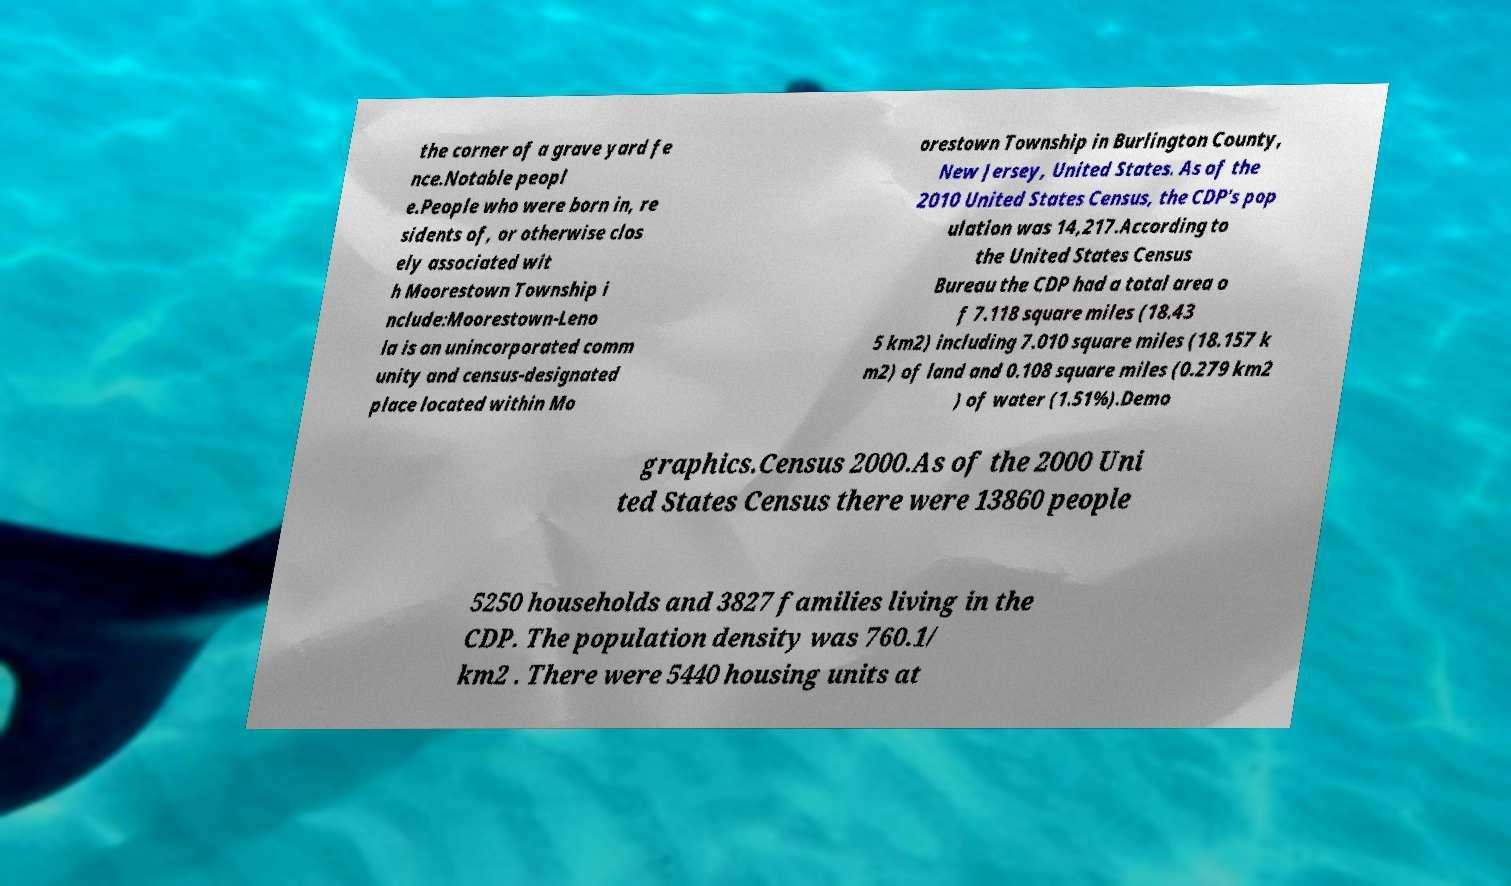Could you assist in decoding the text presented in this image and type it out clearly? the corner of a grave yard fe nce.Notable peopl e.People who were born in, re sidents of, or otherwise clos ely associated wit h Moorestown Township i nclude:Moorestown-Leno la is an unincorporated comm unity and census-designated place located within Mo orestown Township in Burlington County, New Jersey, United States. As of the 2010 United States Census, the CDP's pop ulation was 14,217.According to the United States Census Bureau the CDP had a total area o f 7.118 square miles (18.43 5 km2) including 7.010 square miles (18.157 k m2) of land and 0.108 square miles (0.279 km2 ) of water (1.51%).Demo graphics.Census 2000.As of the 2000 Uni ted States Census there were 13860 people 5250 households and 3827 families living in the CDP. The population density was 760.1/ km2 . There were 5440 housing units at 